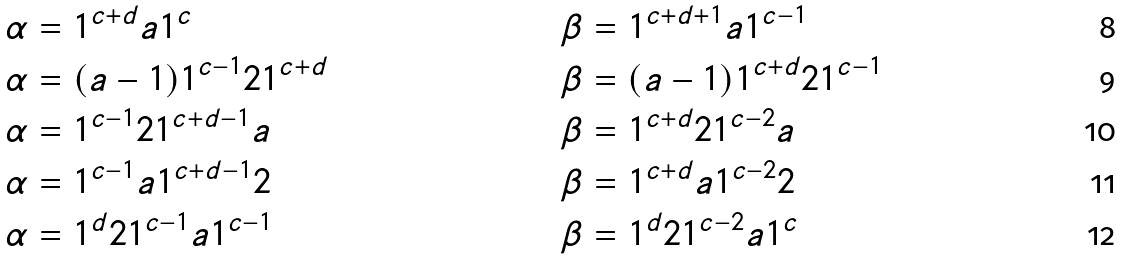<formula> <loc_0><loc_0><loc_500><loc_500>\alpha & = 1 ^ { c + d } a 1 ^ { c } & & \beta = 1 ^ { c + d + 1 } a 1 ^ { c - 1 } \\ \alpha & = ( a - 1 ) 1 ^ { c - 1 } 2 1 ^ { c + d } & & \beta = ( a - 1 ) 1 ^ { c + d } 2 1 ^ { c - 1 } \\ \alpha & = 1 ^ { c - 1 } 2 1 ^ { c + d - 1 } a & & \beta = 1 ^ { c + d } 2 1 ^ { c - 2 } a \\ \alpha & = 1 ^ { c - 1 } a 1 ^ { c + d - 1 } 2 & & \beta = 1 ^ { c + d } a 1 ^ { c - 2 } 2 \\ \alpha & = 1 ^ { d } 2 1 ^ { c - 1 } a 1 ^ { c - 1 } & & \beta = 1 ^ { d } 2 1 ^ { c - 2 } a 1 ^ { c }</formula> 